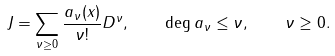Convert formula to latex. <formula><loc_0><loc_0><loc_500><loc_500>J = \sum _ { \nu \geq 0 } \frac { a _ { \nu } ( x ) } { \nu ! } D ^ { \nu } , \quad \deg a _ { \nu } \leq \nu , \quad \nu \geq 0 .</formula> 